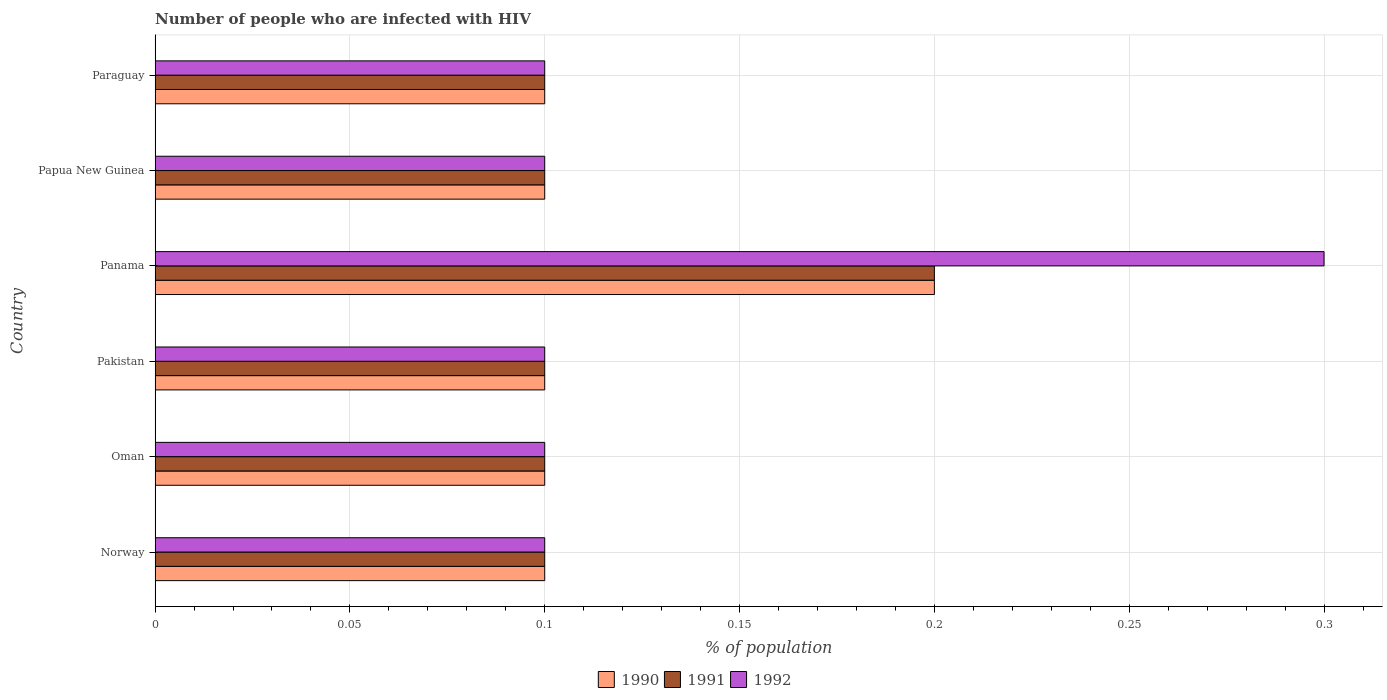How many different coloured bars are there?
Your answer should be very brief. 3. Are the number of bars per tick equal to the number of legend labels?
Your answer should be very brief. Yes. Are the number of bars on each tick of the Y-axis equal?
Your response must be concise. Yes. How many bars are there on the 5th tick from the bottom?
Give a very brief answer. 3. What is the label of the 2nd group of bars from the top?
Your answer should be very brief. Papua New Guinea. In how many cases, is the number of bars for a given country not equal to the number of legend labels?
Your answer should be very brief. 0. What is the percentage of HIV infected population in in 1990 in Norway?
Give a very brief answer. 0.1. Across all countries, what is the maximum percentage of HIV infected population in in 1992?
Offer a very short reply. 0.3. Across all countries, what is the minimum percentage of HIV infected population in in 1991?
Offer a very short reply. 0.1. In which country was the percentage of HIV infected population in in 1990 maximum?
Provide a succinct answer. Panama. What is the total percentage of HIV infected population in in 1991 in the graph?
Offer a very short reply. 0.7. What is the difference between the percentage of HIV infected population in in 1990 in Pakistan and that in Papua New Guinea?
Make the answer very short. 0. What is the difference between the percentage of HIV infected population in in 1990 in Pakistan and the percentage of HIV infected population in in 1992 in Paraguay?
Make the answer very short. 0. What is the average percentage of HIV infected population in in 1992 per country?
Ensure brevity in your answer.  0.13. What is the difference between the percentage of HIV infected population in in 1990 and percentage of HIV infected population in in 1992 in Papua New Guinea?
Keep it short and to the point. 0. What is the difference between the highest and the second highest percentage of HIV infected population in in 1992?
Offer a terse response. 0.2. In how many countries, is the percentage of HIV infected population in in 1991 greater than the average percentage of HIV infected population in in 1991 taken over all countries?
Keep it short and to the point. 1. Is the sum of the percentage of HIV infected population in in 1992 in Pakistan and Papua New Guinea greater than the maximum percentage of HIV infected population in in 1991 across all countries?
Offer a terse response. No. How many bars are there?
Make the answer very short. 18. How many countries are there in the graph?
Your answer should be compact. 6. Where does the legend appear in the graph?
Offer a very short reply. Bottom center. How are the legend labels stacked?
Provide a short and direct response. Horizontal. What is the title of the graph?
Keep it short and to the point. Number of people who are infected with HIV. What is the label or title of the X-axis?
Offer a terse response. % of population. What is the label or title of the Y-axis?
Give a very brief answer. Country. What is the % of population in 1991 in Norway?
Keep it short and to the point. 0.1. What is the % of population in 1990 in Oman?
Your response must be concise. 0.1. What is the % of population in 1990 in Pakistan?
Your answer should be compact. 0.1. What is the % of population in 1991 in Pakistan?
Keep it short and to the point. 0.1. What is the % of population of 1992 in Pakistan?
Ensure brevity in your answer.  0.1. What is the % of population of 1991 in Panama?
Your answer should be compact. 0.2. What is the % of population in 1990 in Papua New Guinea?
Provide a succinct answer. 0.1. What is the % of population of 1991 in Papua New Guinea?
Give a very brief answer. 0.1. What is the % of population in 1992 in Papua New Guinea?
Provide a short and direct response. 0.1. What is the % of population of 1992 in Paraguay?
Offer a very short reply. 0.1. Across all countries, what is the maximum % of population in 1990?
Your response must be concise. 0.2. Across all countries, what is the minimum % of population in 1990?
Your response must be concise. 0.1. Across all countries, what is the minimum % of population of 1991?
Keep it short and to the point. 0.1. What is the difference between the % of population of 1991 in Norway and that in Oman?
Your response must be concise. 0. What is the difference between the % of population in 1992 in Norway and that in Oman?
Offer a terse response. 0. What is the difference between the % of population of 1991 in Norway and that in Panama?
Keep it short and to the point. -0.1. What is the difference between the % of population of 1992 in Norway and that in Panama?
Give a very brief answer. -0.2. What is the difference between the % of population in 1990 in Norway and that in Papua New Guinea?
Your answer should be very brief. 0. What is the difference between the % of population of 1992 in Norway and that in Papua New Guinea?
Provide a succinct answer. 0. What is the difference between the % of population of 1990 in Norway and that in Paraguay?
Provide a succinct answer. 0. What is the difference between the % of population in 1992 in Oman and that in Panama?
Give a very brief answer. -0.2. What is the difference between the % of population in 1992 in Oman and that in Papua New Guinea?
Keep it short and to the point. 0. What is the difference between the % of population of 1991 in Oman and that in Paraguay?
Offer a very short reply. 0. What is the difference between the % of population of 1992 in Oman and that in Paraguay?
Make the answer very short. 0. What is the difference between the % of population of 1990 in Pakistan and that in Panama?
Offer a terse response. -0.1. What is the difference between the % of population in 1991 in Pakistan and that in Panama?
Make the answer very short. -0.1. What is the difference between the % of population in 1990 in Pakistan and that in Papua New Guinea?
Provide a short and direct response. 0. What is the difference between the % of population of 1991 in Pakistan and that in Papua New Guinea?
Your answer should be compact. 0. What is the difference between the % of population in 1992 in Pakistan and that in Papua New Guinea?
Your response must be concise. 0. What is the difference between the % of population in 1991 in Pakistan and that in Paraguay?
Make the answer very short. 0. What is the difference between the % of population of 1992 in Pakistan and that in Paraguay?
Ensure brevity in your answer.  0. What is the difference between the % of population of 1992 in Panama and that in Papua New Guinea?
Your response must be concise. 0.2. What is the difference between the % of population of 1992 in Panama and that in Paraguay?
Make the answer very short. 0.2. What is the difference between the % of population in 1990 in Papua New Guinea and that in Paraguay?
Offer a terse response. 0. What is the difference between the % of population of 1991 in Papua New Guinea and that in Paraguay?
Provide a short and direct response. 0. What is the difference between the % of population of 1990 in Norway and the % of population of 1991 in Pakistan?
Offer a very short reply. 0. What is the difference between the % of population of 1990 in Norway and the % of population of 1992 in Pakistan?
Keep it short and to the point. 0. What is the difference between the % of population in 1991 in Norway and the % of population in 1992 in Pakistan?
Provide a short and direct response. 0. What is the difference between the % of population in 1990 in Norway and the % of population in 1991 in Papua New Guinea?
Your answer should be very brief. 0. What is the difference between the % of population in 1991 in Norway and the % of population in 1992 in Papua New Guinea?
Provide a succinct answer. 0. What is the difference between the % of population in 1990 in Norway and the % of population in 1992 in Paraguay?
Keep it short and to the point. 0. What is the difference between the % of population of 1991 in Oman and the % of population of 1992 in Pakistan?
Ensure brevity in your answer.  0. What is the difference between the % of population of 1990 in Oman and the % of population of 1992 in Panama?
Provide a short and direct response. -0.2. What is the difference between the % of population in 1991 in Oman and the % of population in 1992 in Panama?
Provide a succinct answer. -0.2. What is the difference between the % of population of 1991 in Oman and the % of population of 1992 in Papua New Guinea?
Your answer should be compact. 0. What is the difference between the % of population in 1990 in Oman and the % of population in 1991 in Paraguay?
Provide a succinct answer. 0. What is the difference between the % of population in 1990 in Pakistan and the % of population in 1991 in Panama?
Keep it short and to the point. -0.1. What is the difference between the % of population in 1991 in Pakistan and the % of population in 1992 in Panama?
Give a very brief answer. -0.2. What is the difference between the % of population of 1990 in Pakistan and the % of population of 1992 in Papua New Guinea?
Ensure brevity in your answer.  0. What is the difference between the % of population of 1990 in Pakistan and the % of population of 1992 in Paraguay?
Offer a terse response. 0. What is the difference between the % of population of 1990 in Panama and the % of population of 1991 in Papua New Guinea?
Offer a terse response. 0.1. What is the difference between the % of population of 1991 in Panama and the % of population of 1992 in Papua New Guinea?
Offer a very short reply. 0.1. What is the difference between the % of population of 1990 in Panama and the % of population of 1991 in Paraguay?
Offer a terse response. 0.1. What is the difference between the % of population of 1990 in Panama and the % of population of 1992 in Paraguay?
Provide a short and direct response. 0.1. What is the difference between the % of population in 1991 in Panama and the % of population in 1992 in Paraguay?
Provide a short and direct response. 0.1. What is the difference between the % of population in 1990 in Papua New Guinea and the % of population in 1992 in Paraguay?
Provide a short and direct response. 0. What is the average % of population of 1990 per country?
Offer a very short reply. 0.12. What is the average % of population of 1991 per country?
Make the answer very short. 0.12. What is the average % of population in 1992 per country?
Make the answer very short. 0.13. What is the difference between the % of population of 1990 and % of population of 1991 in Norway?
Your answer should be compact. 0. What is the difference between the % of population in 1991 and % of population in 1992 in Norway?
Offer a terse response. 0. What is the difference between the % of population in 1990 and % of population in 1991 in Pakistan?
Give a very brief answer. 0. What is the difference between the % of population in 1991 and % of population in 1992 in Pakistan?
Offer a terse response. 0. What is the difference between the % of population in 1990 and % of population in 1992 in Panama?
Offer a terse response. -0.1. What is the difference between the % of population in 1990 and % of population in 1992 in Paraguay?
Offer a terse response. 0. What is the difference between the % of population in 1991 and % of population in 1992 in Paraguay?
Provide a succinct answer. 0. What is the ratio of the % of population of 1990 in Norway to that in Oman?
Ensure brevity in your answer.  1. What is the ratio of the % of population of 1992 in Norway to that in Oman?
Give a very brief answer. 1. What is the ratio of the % of population of 1990 in Norway to that in Pakistan?
Give a very brief answer. 1. What is the ratio of the % of population in 1991 in Norway to that in Pakistan?
Give a very brief answer. 1. What is the ratio of the % of population in 1992 in Norway to that in Panama?
Provide a succinct answer. 0.33. What is the ratio of the % of population in 1991 in Norway to that in Papua New Guinea?
Provide a succinct answer. 1. What is the ratio of the % of population of 1990 in Norway to that in Paraguay?
Ensure brevity in your answer.  1. What is the ratio of the % of population in 1991 in Norway to that in Paraguay?
Keep it short and to the point. 1. What is the ratio of the % of population in 1992 in Norway to that in Paraguay?
Offer a terse response. 1. What is the ratio of the % of population of 1990 in Oman to that in Pakistan?
Keep it short and to the point. 1. What is the ratio of the % of population of 1991 in Oman to that in Pakistan?
Your answer should be compact. 1. What is the ratio of the % of population in 1992 in Oman to that in Pakistan?
Give a very brief answer. 1. What is the ratio of the % of population in 1991 in Oman to that in Papua New Guinea?
Your answer should be compact. 1. What is the ratio of the % of population in 1990 in Oman to that in Paraguay?
Ensure brevity in your answer.  1. What is the ratio of the % of population in 1992 in Oman to that in Paraguay?
Give a very brief answer. 1. What is the ratio of the % of population in 1990 in Pakistan to that in Panama?
Provide a succinct answer. 0.5. What is the ratio of the % of population of 1991 in Pakistan to that in Panama?
Your answer should be compact. 0.5. What is the ratio of the % of population of 1991 in Pakistan to that in Papua New Guinea?
Give a very brief answer. 1. What is the ratio of the % of population of 1992 in Pakistan to that in Papua New Guinea?
Provide a short and direct response. 1. What is the ratio of the % of population in 1990 in Pakistan to that in Paraguay?
Make the answer very short. 1. What is the ratio of the % of population in 1992 in Pakistan to that in Paraguay?
Give a very brief answer. 1. What is the ratio of the % of population of 1990 in Panama to that in Papua New Guinea?
Offer a terse response. 2. What is the ratio of the % of population in 1991 in Panama to that in Papua New Guinea?
Offer a very short reply. 2. What is the ratio of the % of population in 1992 in Panama to that in Papua New Guinea?
Provide a short and direct response. 3. What is the ratio of the % of population in 1991 in Panama to that in Paraguay?
Your answer should be compact. 2. What is the ratio of the % of population of 1992 in Panama to that in Paraguay?
Provide a succinct answer. 3. What is the ratio of the % of population of 1991 in Papua New Guinea to that in Paraguay?
Make the answer very short. 1. What is the ratio of the % of population of 1992 in Papua New Guinea to that in Paraguay?
Keep it short and to the point. 1. What is the difference between the highest and the second highest % of population of 1990?
Offer a terse response. 0.1. What is the difference between the highest and the second highest % of population in 1992?
Your response must be concise. 0.2. 